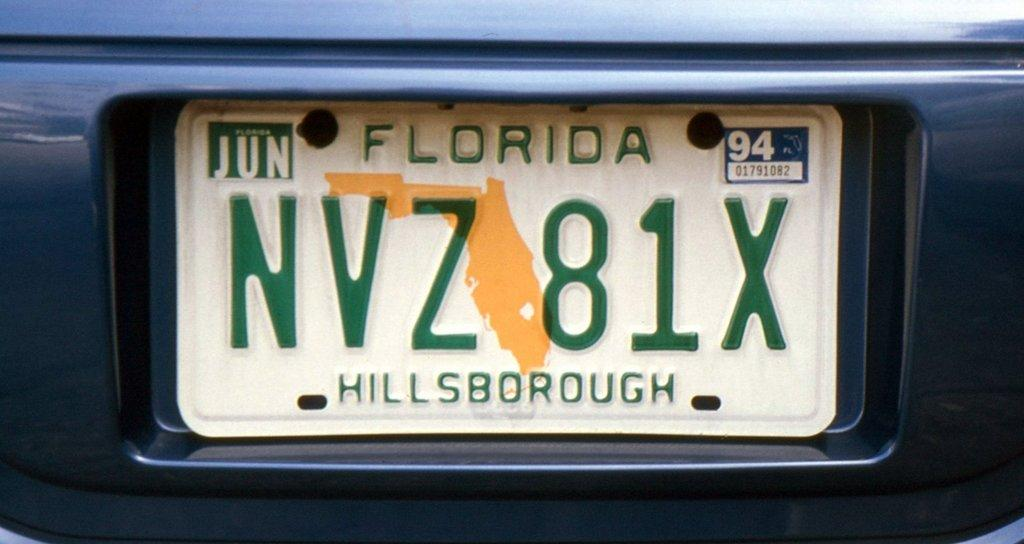<image>
Present a compact description of the photo's key features. A closeup of a Florida licence plate in Hillsborough county which is NVZ 81X. 